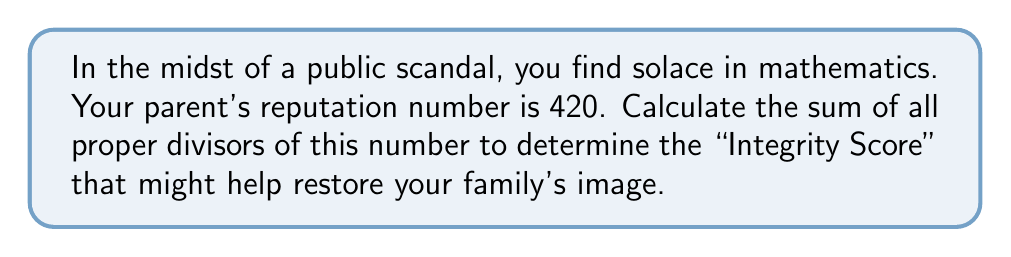Can you solve this math problem? Let's approach this step-by-step:

1) First, we need to find all the proper divisors of 420. Proper divisors are all positive divisors of a number excluding the number itself.

2) To find the divisors, let's factorize 420:
   $420 = 2^2 \times 3 \times 5 \times 7$

3) Now, we can list all the divisors:
   1 (always a divisor)
   2, 4 (from $2^2$)
   3 (from 3)
   5 (from 5)
   7 (from 7)
   6 (2 × 3), 10 (2 × 5), 14 (2 × 7)
   12 (3 × 4), 20 (4 × 5), 28 (4 × 7)
   15 (3 × 5), 21 (3 × 7)
   35 (5 × 7)
   30 (2 × 3 × 5), 42 (2 × 3 × 7), 70 (2 × 5 × 7)
   60 (3 × 4 × 5), 84 (3 × 4 × 7)
   105 (3 × 5 × 7)
   140 (4 × 5 × 7)
   210 (2 × 3 × 5 × 7)

4) Now, we sum all these proper divisors:

   $$1 + 2 + 3 + 4 + 5 + 6 + 7 + 10 + 12 + 14 + 15 + 20 + 21 + 28 + 30 + 35 + 42 + 60 + 70 + 84 + 105 + 140 + 210 = 924$$

Therefore, the sum of all proper divisors of 420 is 924.
Answer: 924 